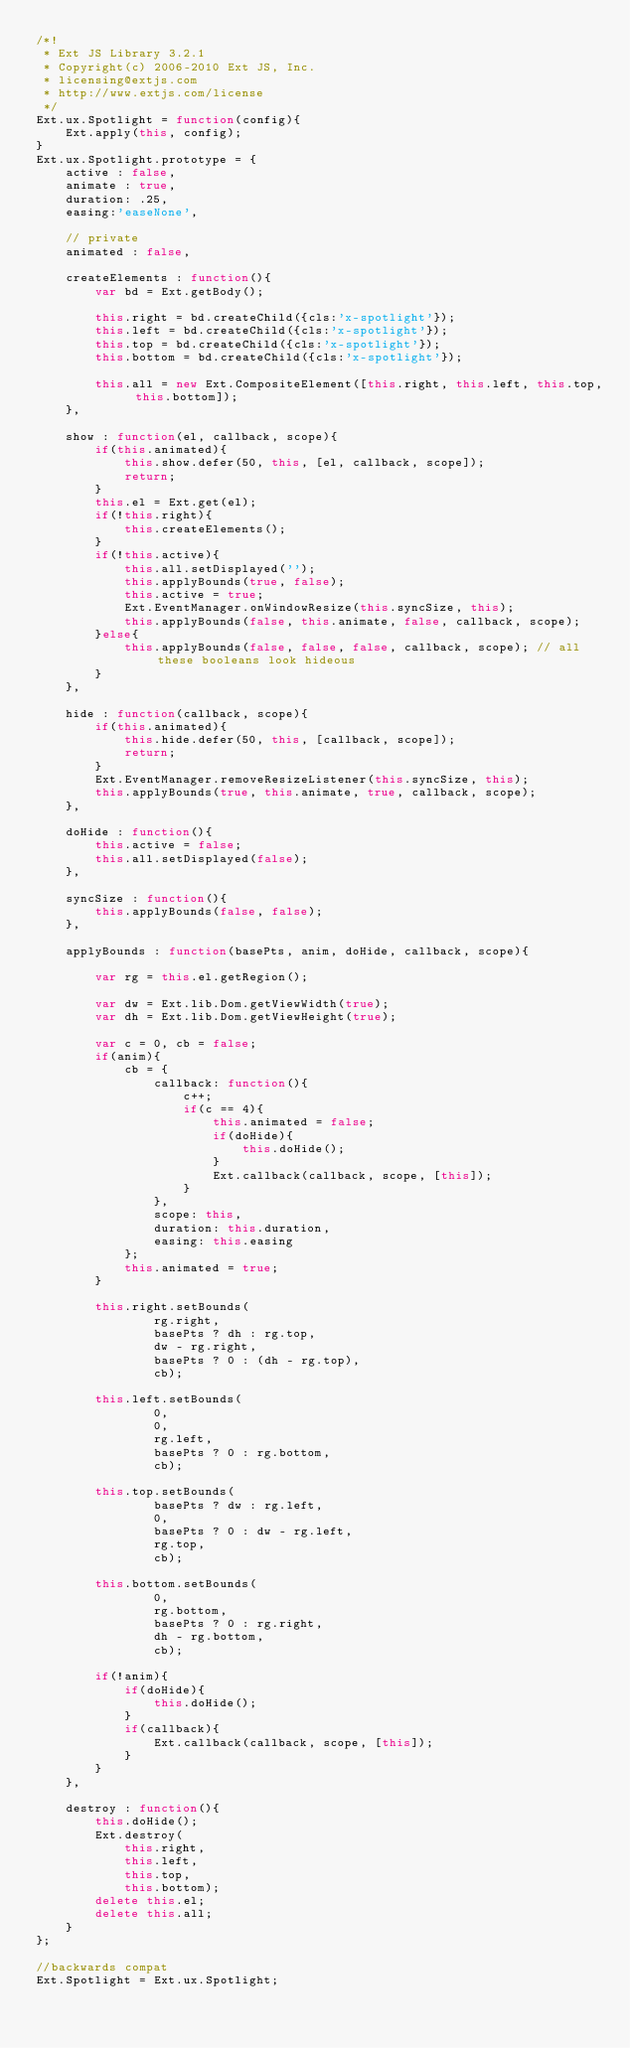Convert code to text. <code><loc_0><loc_0><loc_500><loc_500><_JavaScript_>/*!
 * Ext JS Library 3.2.1
 * Copyright(c) 2006-2010 Ext JS, Inc.
 * licensing@extjs.com
 * http://www.extjs.com/license
 */
Ext.ux.Spotlight = function(config){
    Ext.apply(this, config);
}
Ext.ux.Spotlight.prototype = {
    active : false,
    animate : true,
    duration: .25,
    easing:'easeNone',

    // private
    animated : false,

    createElements : function(){
        var bd = Ext.getBody();

        this.right = bd.createChild({cls:'x-spotlight'});
        this.left = bd.createChild({cls:'x-spotlight'});
        this.top = bd.createChild({cls:'x-spotlight'});
        this.bottom = bd.createChild({cls:'x-spotlight'});

        this.all = new Ext.CompositeElement([this.right, this.left, this.top, this.bottom]);
    },

    show : function(el, callback, scope){
        if(this.animated){
            this.show.defer(50, this, [el, callback, scope]);
            return;
        }
        this.el = Ext.get(el);
        if(!this.right){
            this.createElements();
        }
        if(!this.active){
            this.all.setDisplayed('');
            this.applyBounds(true, false);
            this.active = true;
            Ext.EventManager.onWindowResize(this.syncSize, this);
            this.applyBounds(false, this.animate, false, callback, scope);
        }else{
            this.applyBounds(false, false, false, callback, scope); // all these booleans look hideous
        }
    },

    hide : function(callback, scope){
        if(this.animated){
            this.hide.defer(50, this, [callback, scope]);
            return;
        }
        Ext.EventManager.removeResizeListener(this.syncSize, this);
        this.applyBounds(true, this.animate, true, callback, scope);
    },

    doHide : function(){
        this.active = false;
        this.all.setDisplayed(false);
    },

    syncSize : function(){
        this.applyBounds(false, false);
    },

    applyBounds : function(basePts, anim, doHide, callback, scope){

        var rg = this.el.getRegion();

        var dw = Ext.lib.Dom.getViewWidth(true);
        var dh = Ext.lib.Dom.getViewHeight(true);

        var c = 0, cb = false;
        if(anim){
            cb = {
                callback: function(){
                    c++;
                    if(c == 4){
                        this.animated = false;
                        if(doHide){
                            this.doHide();
                        }
                        Ext.callback(callback, scope, [this]);
                    }
                },
                scope: this,
                duration: this.duration,
                easing: this.easing
            };
            this.animated = true;
        }

        this.right.setBounds(
                rg.right,
                basePts ? dh : rg.top,
                dw - rg.right,
                basePts ? 0 : (dh - rg.top),
                cb);

        this.left.setBounds(
                0,
                0,
                rg.left,
                basePts ? 0 : rg.bottom,
                cb);

        this.top.setBounds(
                basePts ? dw : rg.left,
                0,
                basePts ? 0 : dw - rg.left,
                rg.top,
                cb);

        this.bottom.setBounds(
                0,
                rg.bottom,
                basePts ? 0 : rg.right,
                dh - rg.bottom,
                cb);

        if(!anim){
            if(doHide){
                this.doHide();
            }
            if(callback){
                Ext.callback(callback, scope, [this]);
            }
        }
    },

    destroy : function(){
        this.doHide();
        Ext.destroy(
            this.right,
            this.left,
            this.top,
            this.bottom);
        delete this.el;
        delete this.all;
    }
};

//backwards compat
Ext.Spotlight = Ext.ux.Spotlight;</code> 